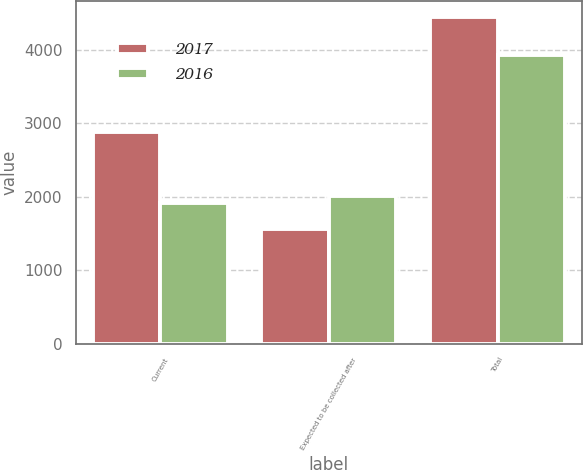Convert chart to OTSL. <chart><loc_0><loc_0><loc_500><loc_500><stacked_bar_chart><ecel><fcel>Current<fcel>Expected to be collected after<fcel>Total<nl><fcel>2017<fcel>2876<fcel>1564<fcel>4440<nl><fcel>2016<fcel>1919<fcel>2011<fcel>3930<nl></chart> 